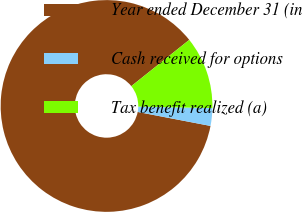Convert chart to OTSL. <chart><loc_0><loc_0><loc_500><loc_500><pie_chart><fcel>Year ended December 31 (in<fcel>Cash received for options<fcel>Tax benefit realized (a)<nl><fcel>86.25%<fcel>2.7%<fcel>11.05%<nl></chart> 